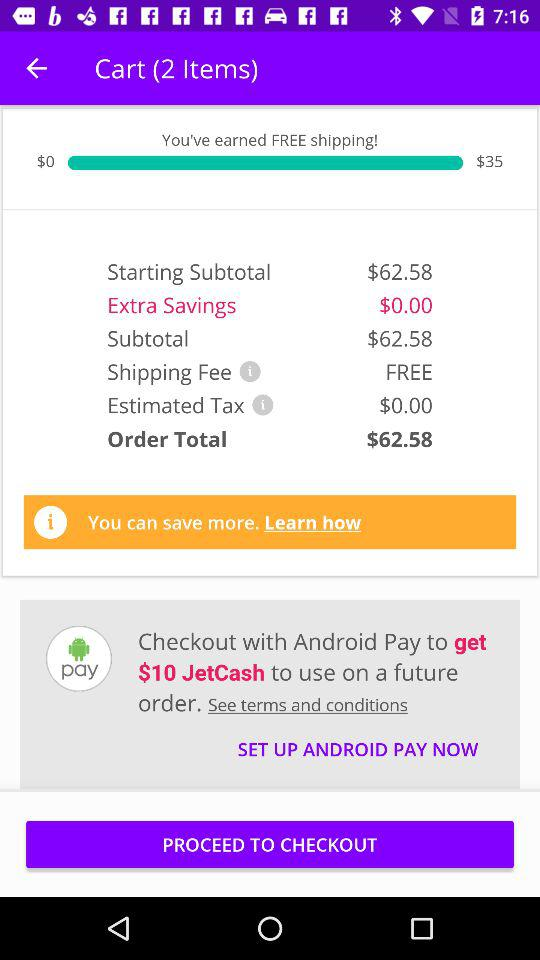How much do I have to pay for the order?
Answer the question using a single word or phrase. $62.58 